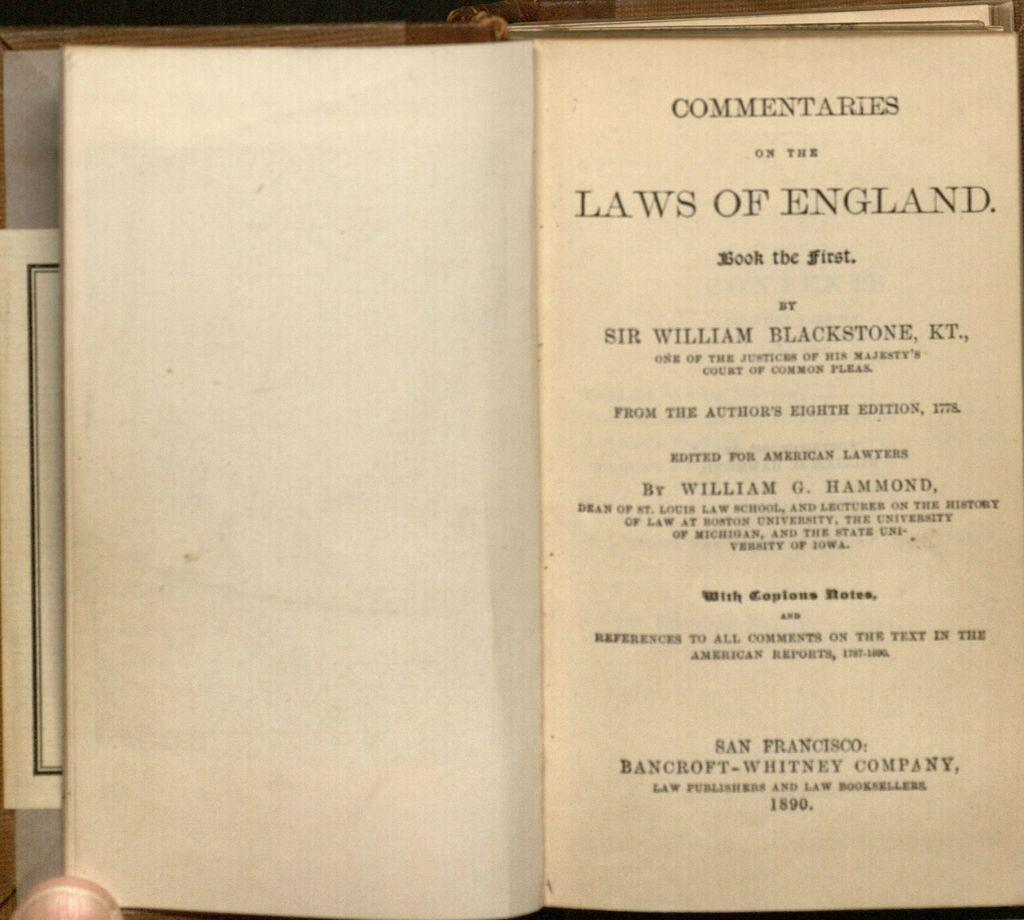<image>
Relay a brief, clear account of the picture shown. A book about English law is opened to the title page. 